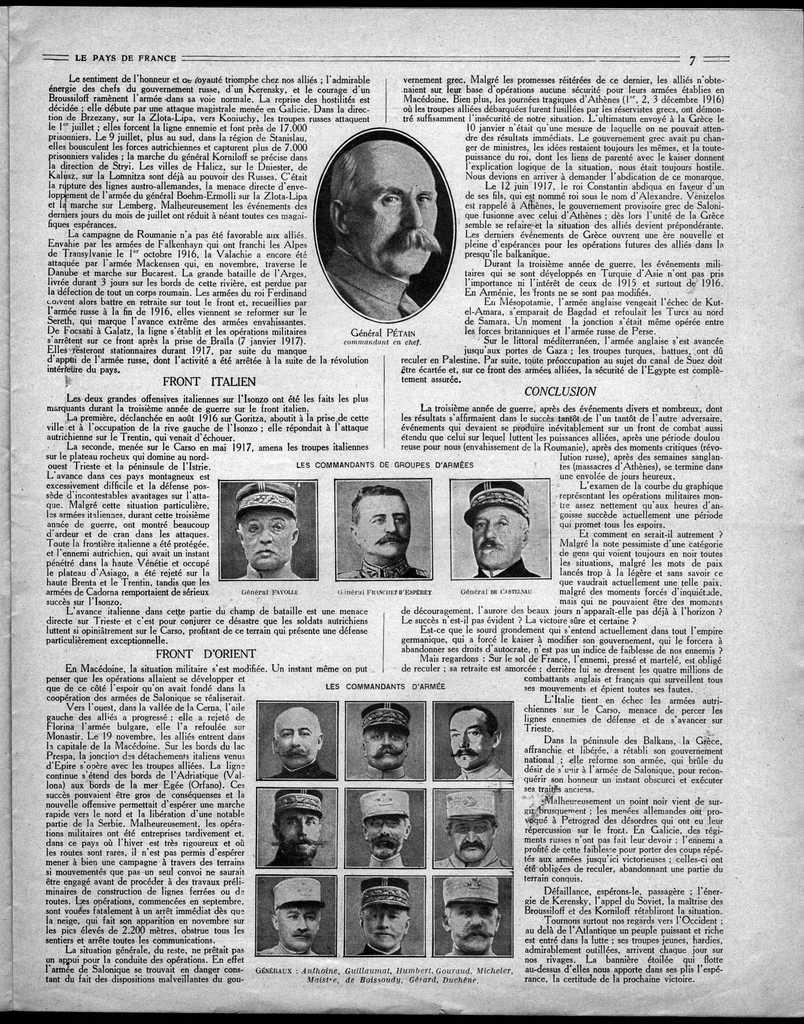What is present on the paper in the image? There is a paper in the image, and text is printed on it. Are there any visual elements on the paper besides text? Yes, there are pictures of persons printed on the paper. What type of bells can be heard ringing in the image? There are no bells present in the image, and therefore no sound can be heard. 